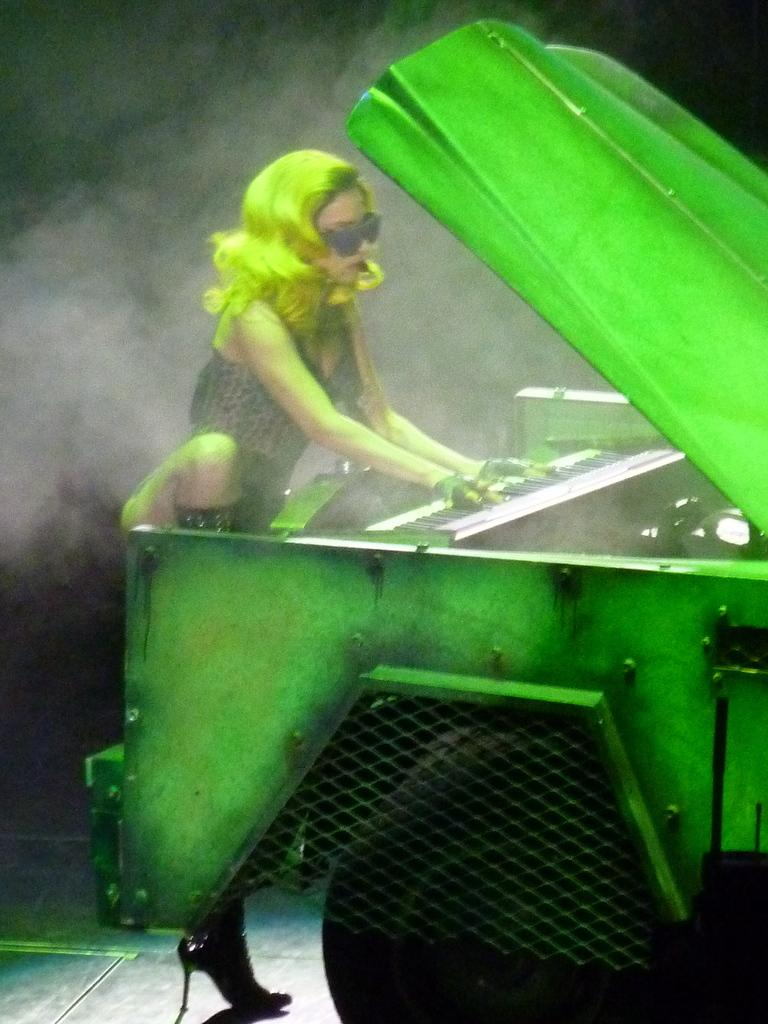What is the woman in the image doing? The woman is playing a keyboard. What else can be seen in the image besides the woman? There is a vehicle visible in the image. What is the condition of the background in the image? The background of the image is dark. Can you describe any other elements in the image? Yes, smoke is present in the image. Where is the dog buried in the cemetery shown in the image? There is no cemetery or dog present in the image. 